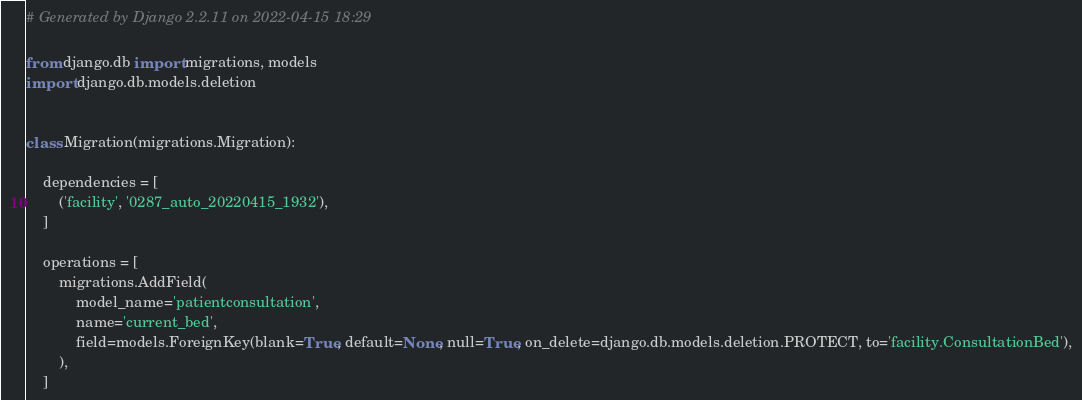<code> <loc_0><loc_0><loc_500><loc_500><_Python_># Generated by Django 2.2.11 on 2022-04-15 18:29

from django.db import migrations, models
import django.db.models.deletion


class Migration(migrations.Migration):

    dependencies = [
        ('facility', '0287_auto_20220415_1932'),
    ]

    operations = [
        migrations.AddField(
            model_name='patientconsultation',
            name='current_bed',
            field=models.ForeignKey(blank=True, default=None, null=True, on_delete=django.db.models.deletion.PROTECT, to='facility.ConsultationBed'),
        ),
    ]
</code> 